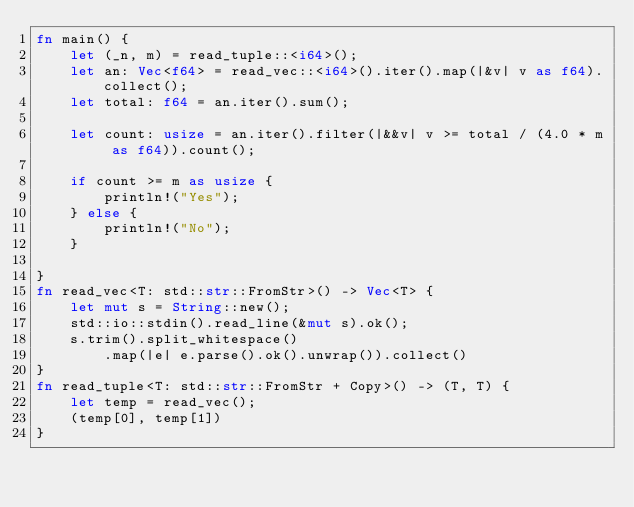<code> <loc_0><loc_0><loc_500><loc_500><_Rust_>fn main() {
    let (_n, m) = read_tuple::<i64>();
    let an: Vec<f64> = read_vec::<i64>().iter().map(|&v| v as f64).collect();
    let total: f64 = an.iter().sum();

    let count: usize = an.iter().filter(|&&v| v >= total / (4.0 * m as f64)).count();

    if count >= m as usize {
        println!("Yes");
    } else {
        println!("No");
    }

}
fn read_vec<T: std::str::FromStr>() -> Vec<T> {
    let mut s = String::new();
    std::io::stdin().read_line(&mut s).ok();
    s.trim().split_whitespace()
        .map(|e| e.parse().ok().unwrap()).collect()
}
fn read_tuple<T: std::str::FromStr + Copy>() -> (T, T) {
    let temp = read_vec();
    (temp[0], temp[1])
}

</code> 